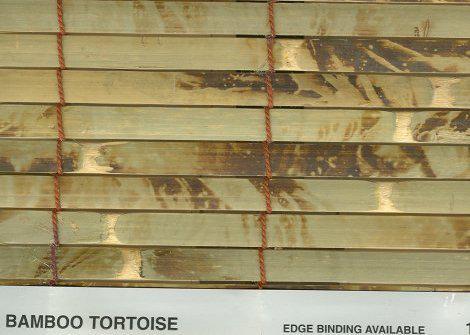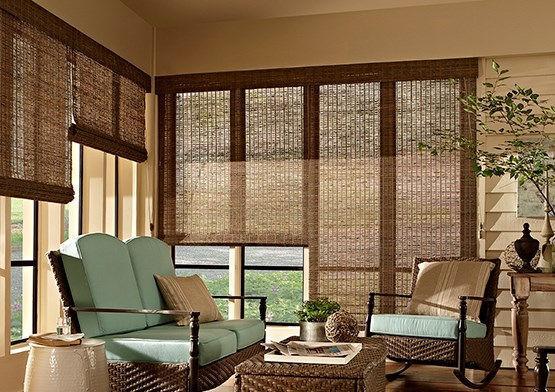The first image is the image on the left, the second image is the image on the right. For the images displayed, is the sentence "There are exactly three shades in the left image." factually correct? Answer yes or no. No. 